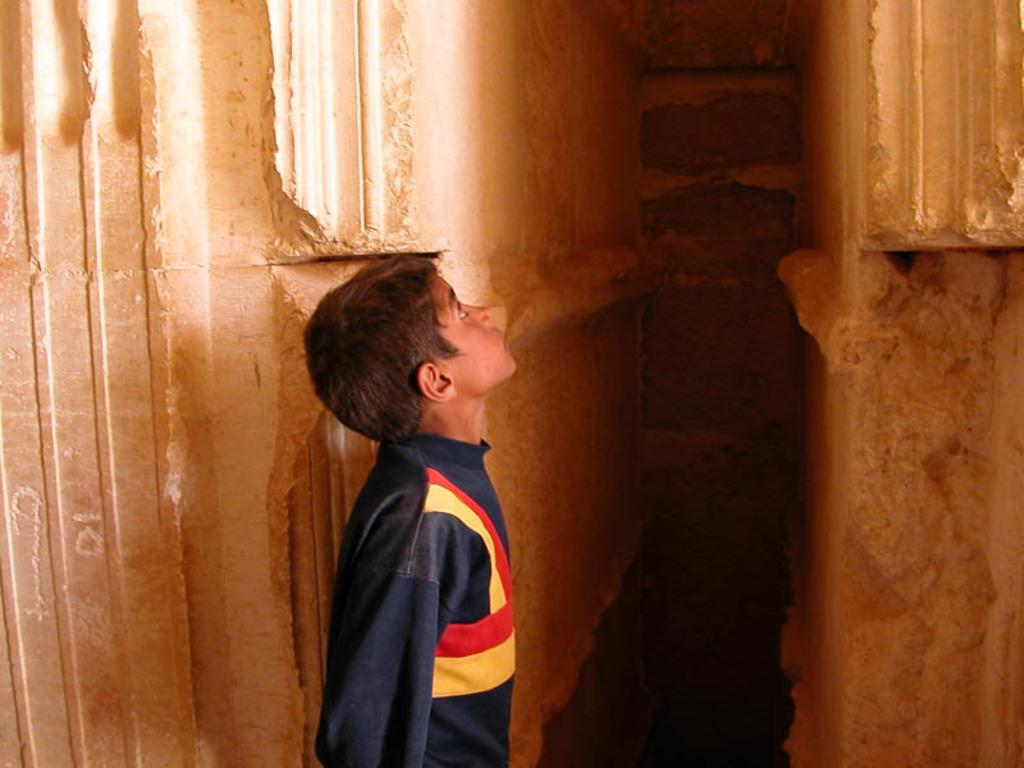Who or what is present in the image? There is a person in the image. What is the person wearing? The person is wearing a dress with blue, yellow, and red colors. What can be seen in the background of the image? There is a wall visible in the image. Which direction is the person facing in the image? The provided facts do not mention the direction the person is facing, so it cannot be determined from the image. What type of ray is visible in the image? There is no ray present in the image. 